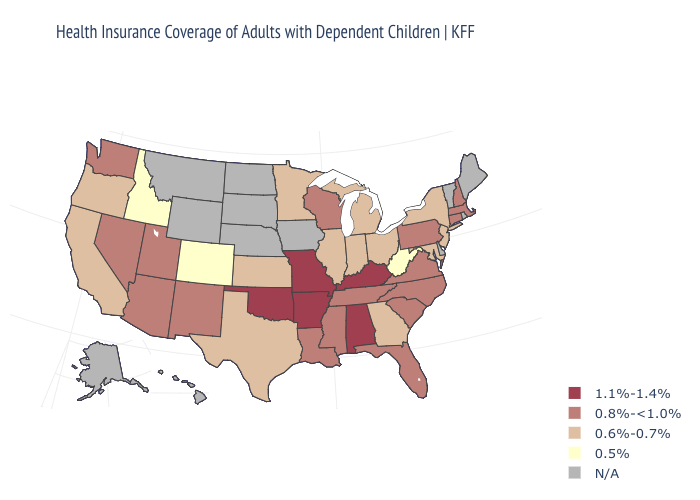Among the states that border Maine , which have the highest value?
Answer briefly. New Hampshire. What is the lowest value in the USA?
Be succinct. 0.5%. Does South Carolina have the lowest value in the USA?
Short answer required. No. Name the states that have a value in the range 0.5%?
Answer briefly. Colorado, Idaho, West Virginia. Is the legend a continuous bar?
Answer briefly. No. What is the value of Louisiana?
Give a very brief answer. 0.8%-<1.0%. Name the states that have a value in the range 0.8%-<1.0%?
Give a very brief answer. Arizona, Connecticut, Florida, Louisiana, Massachusetts, Mississippi, Nevada, New Hampshire, New Mexico, North Carolina, Pennsylvania, South Carolina, Tennessee, Utah, Virginia, Washington, Wisconsin. Name the states that have a value in the range 0.8%-<1.0%?
Be succinct. Arizona, Connecticut, Florida, Louisiana, Massachusetts, Mississippi, Nevada, New Hampshire, New Mexico, North Carolina, Pennsylvania, South Carolina, Tennessee, Utah, Virginia, Washington, Wisconsin. What is the value of Kentucky?
Keep it brief. 1.1%-1.4%. What is the highest value in states that border New Hampshire?
Be succinct. 0.8%-<1.0%. Does Wisconsin have the highest value in the MidWest?
Be succinct. No. What is the lowest value in states that border North Dakota?
Write a very short answer. 0.6%-0.7%. What is the value of Wisconsin?
Keep it brief. 0.8%-<1.0%. 